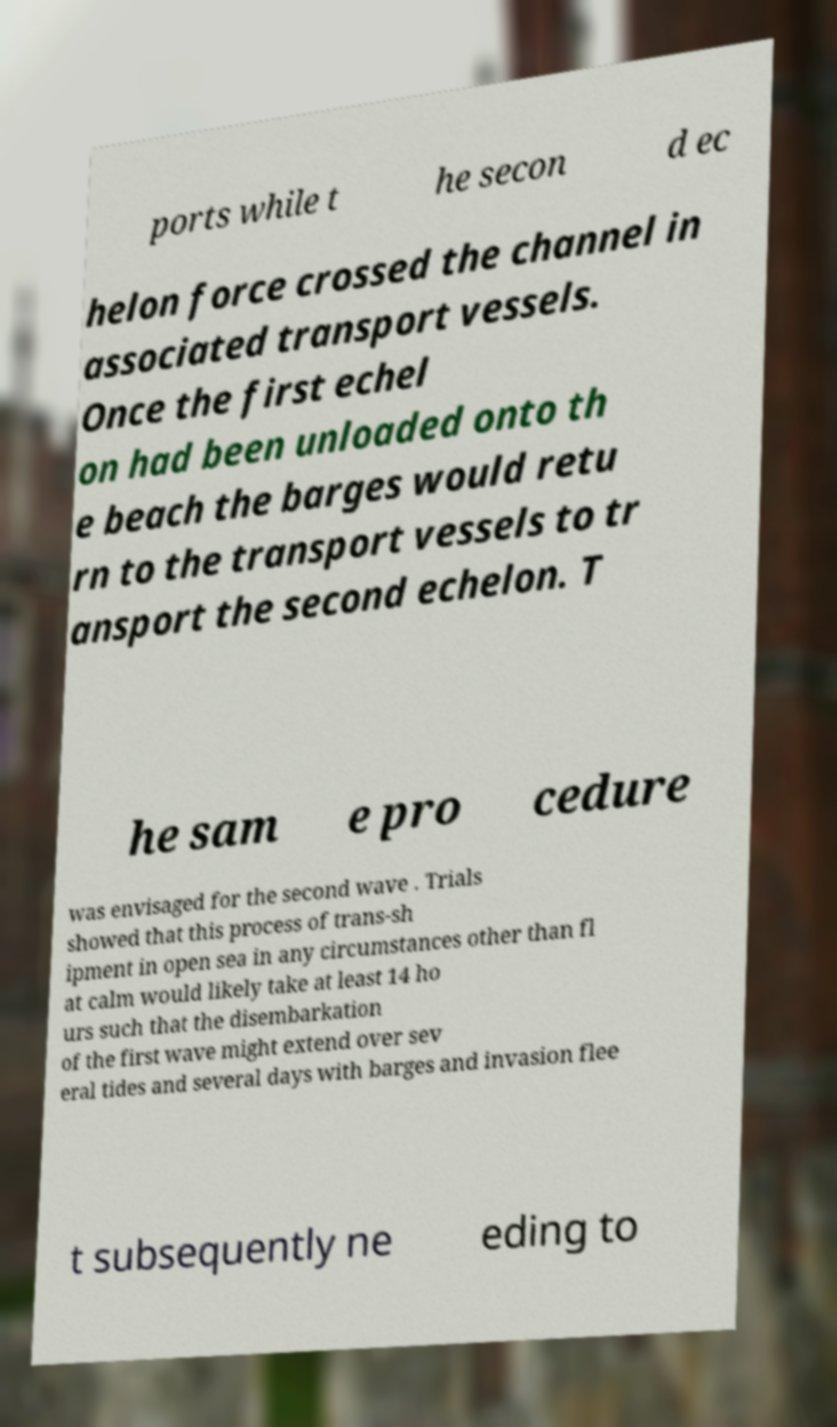Please identify and transcribe the text found in this image. ports while t he secon d ec helon force crossed the channel in associated transport vessels. Once the first echel on had been unloaded onto th e beach the barges would retu rn to the transport vessels to tr ansport the second echelon. T he sam e pro cedure was envisaged for the second wave . Trials showed that this process of trans-sh ipment in open sea in any circumstances other than fl at calm would likely take at least 14 ho urs such that the disembarkation of the first wave might extend over sev eral tides and several days with barges and invasion flee t subsequently ne eding to 